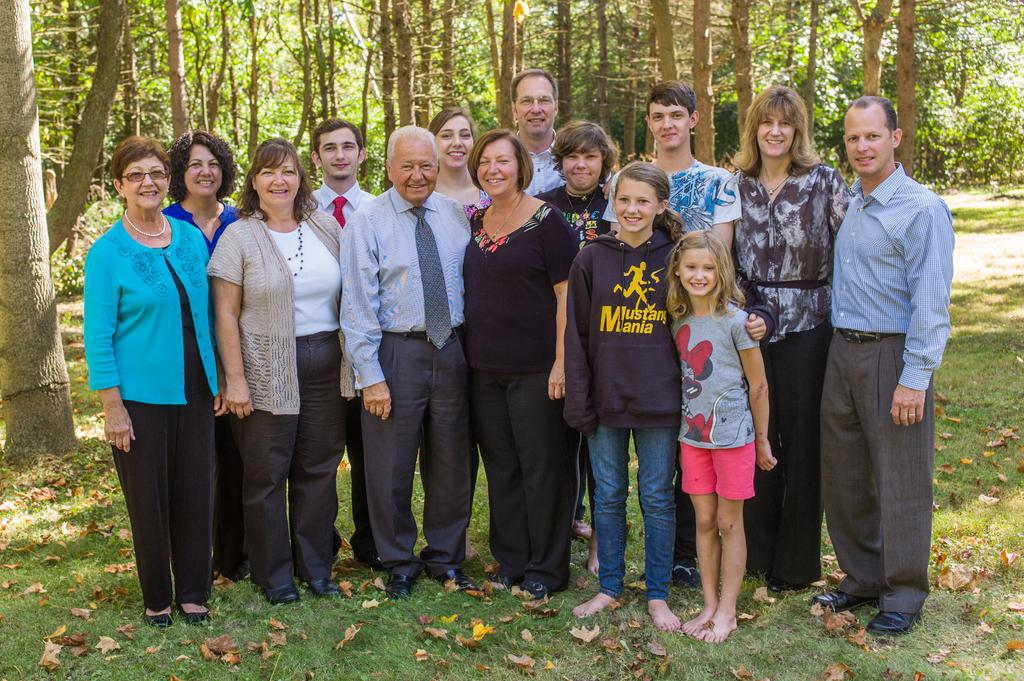How many people are in the image? There is a group of people in the image. What are the people standing on? The people are standing on a grass surface. What is the facial expression of the people in the image? The people are smiling. What can be seen in the background of the image? There are trees visible in the background of the image. What type of bread is being shared among the people in the image? There is no bread present in the image; it features a group of people standing on a grass surface and smiling. What is the opinion of the pig in the image? There is no pig present in the image, so it is not possible to determine its opinion. 